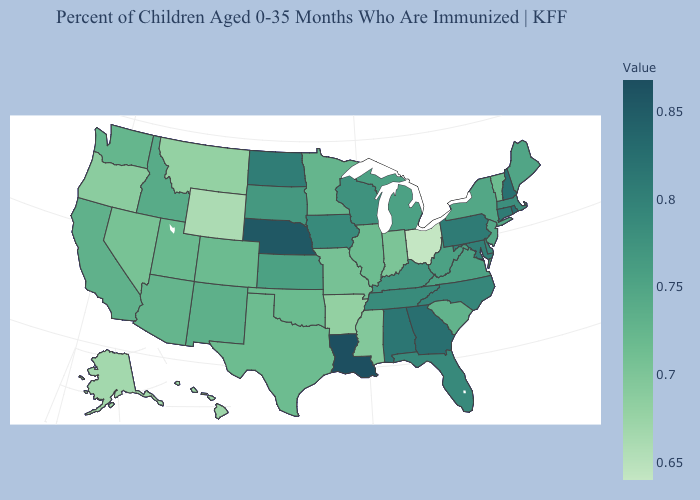Which states have the lowest value in the West?
Keep it brief. Wyoming. Among the states that border Texas , which have the highest value?
Quick response, please. Louisiana. Does Alabama have a lower value than South Carolina?
Short answer required. No. Does Kentucky have the lowest value in the USA?
Quick response, please. No. Does the map have missing data?
Short answer required. No. 